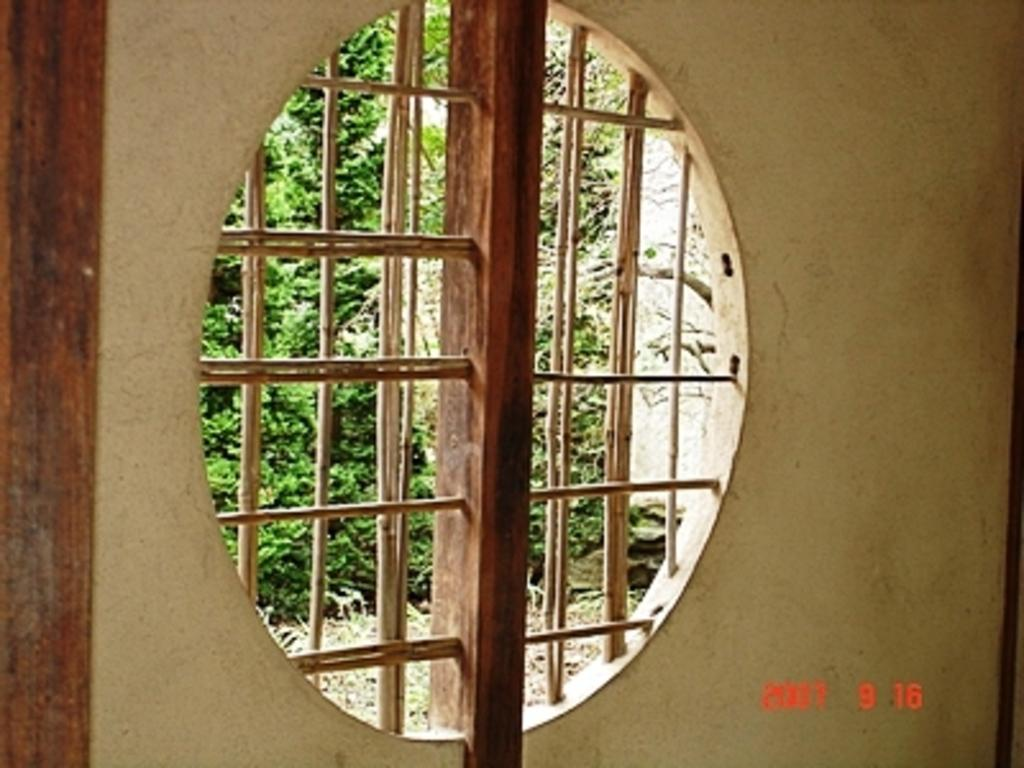What is located in the center of the image? There is a window in the center of the image. What can be seen through the window? Trees are visible through the window. What is another feature of the image besides the window? There is a wall in the image. What is written or displayed at the bottom of the image? There is some text at the bottom of the image. What type of beast can be seen washing itself in the basin in the image? There is no beast or basin present in the image. 